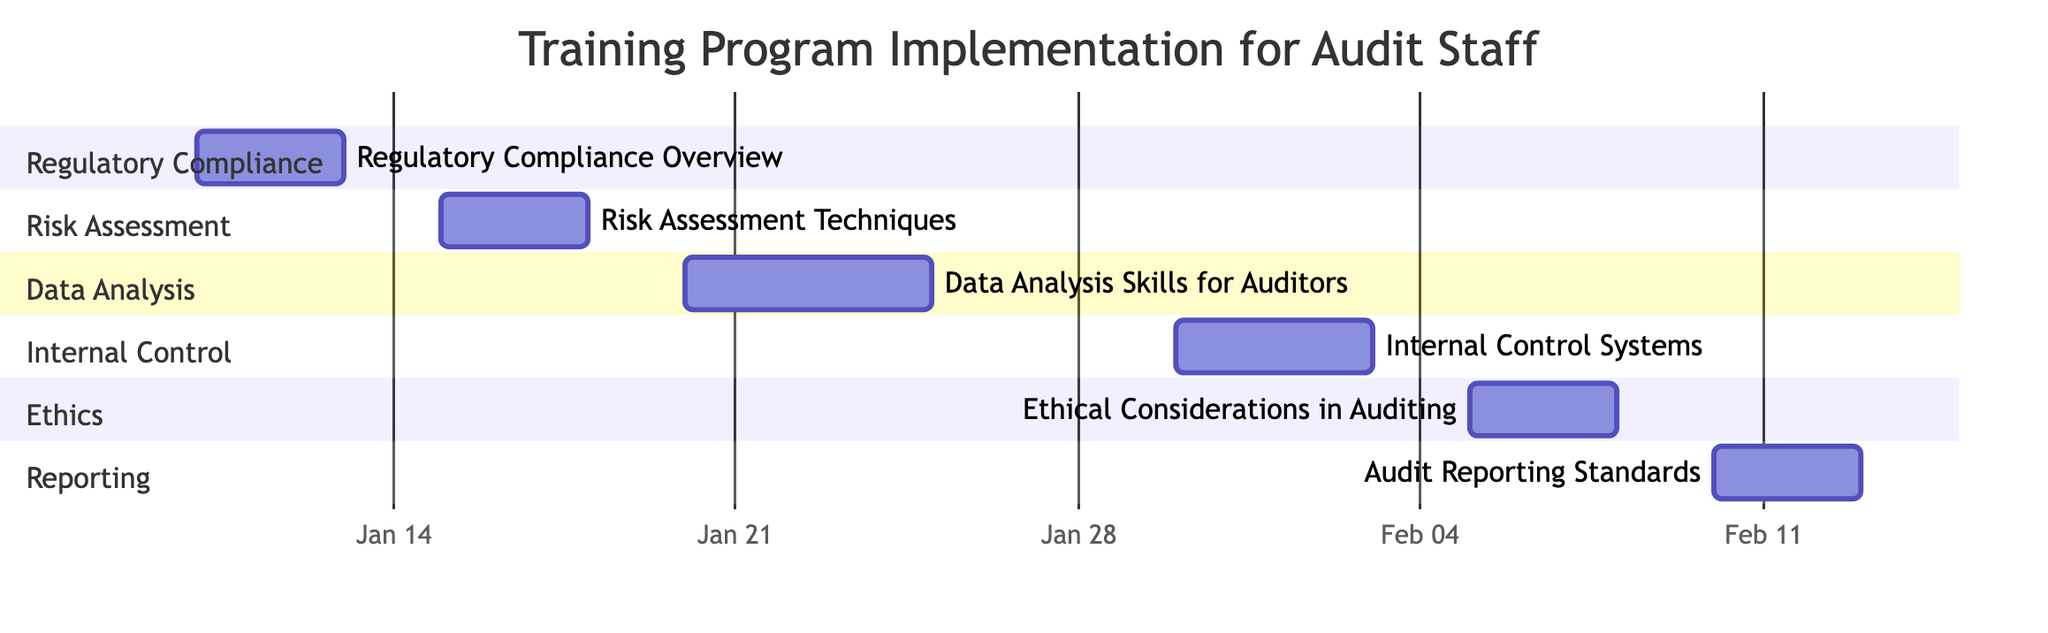What is the duration of the 'Regulatory Compliance Overview' session? The 'Regulatory Compliance Overview' session has a duration of 3 days as indicated in the diagram where the session column explicitly shows the duration alongside each session.
Answer: 3 days What is the start date of the 'Internal Control Systems' session? The start date for the 'Internal Control Systems' session is shown as January 30, 2024, outlined in the project's timeline section for that specific session.
Answer: January 30, 2024 How many total training sessions are listed in the chart? The chart lists a total of 6 training sessions under different categories, which can be confirmed by counting the sessions provided in the data structure.
Answer: 6 Which session follows 'Risk Assessment Techniques'? The session that follows 'Risk Assessment Techniques' is 'Data Analysis Skills for Auditors', as the timeline indicates that the latter starts right after the former ends.
Answer: Data Analysis Skills for Auditors What is the end date of the last session in the chart? The end date of the last session, 'Audit Reporting Standards', is February 12, 2024, which can be located at the end of its timeline entry in the chart.
Answer: February 12, 2024 Which session has topics including 'Professional Ethics'? The session that includes the topic 'Professional Ethics' is 'Ethical Considerations in Auditing', as shown in the topics listed beside the corresponding session in the chart.
Answer: Ethical Considerations in Auditing How many completed training sessions are there? According to the progress tracking section in the data, there are 0 completed sessions as stated directly in the completion summary presented.
Answer: 0 What is the total number of upcoming sessions? The total number of upcoming sessions is listed as 6 in the progress tracking section, confirming that all planned sessions are still awaiting commencement.
Answer: 6 What is the specific end date of the 'Data Analysis Skills for Auditors' session? The end date for 'Data Analysis Skills for Auditors' is February 24, 2024, which is reported alongside the timeline for that specific session in the Gantt chart.
Answer: February 24, 2024 